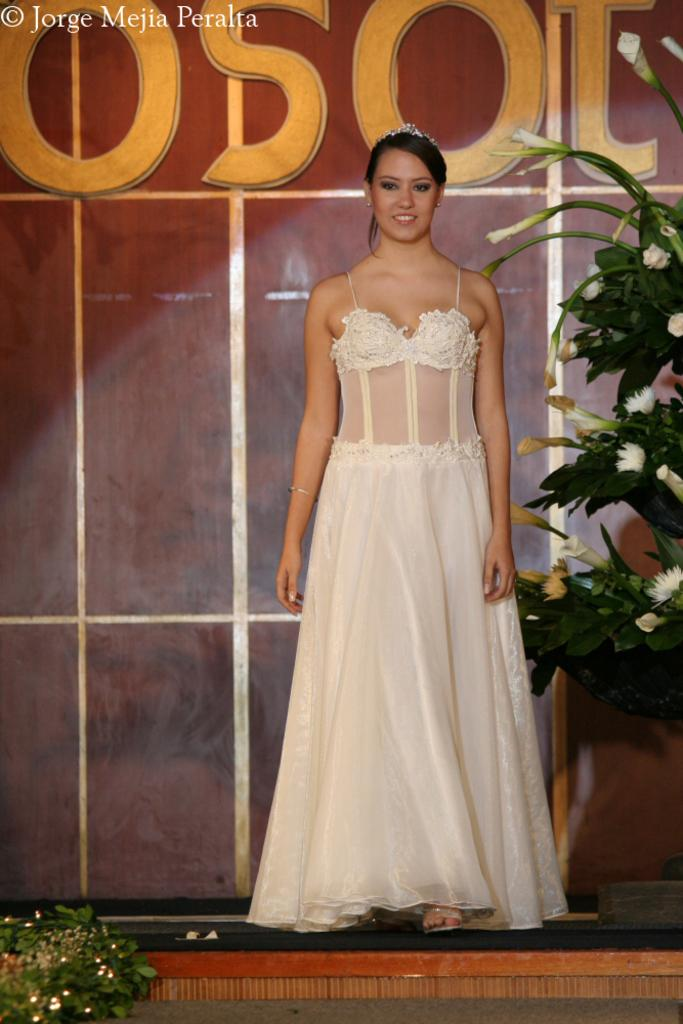What is the main subject in the image? There is a woman standing in the image. Where is the woman standing? The woman is standing on the floor. What type of vegetation can be seen in the image? There are plants with flowers in the image. What is visible behind the woman? There is a wall visible in the image. What is written or displayed on the wall? There is text on the wall. Can you describe the zephyr blowing through the window in the image? There is no window or zephyr present in the image. What type of sheet is draped over the woman in the image? There is no sheet present in the image; the woman is standing without any covering. 